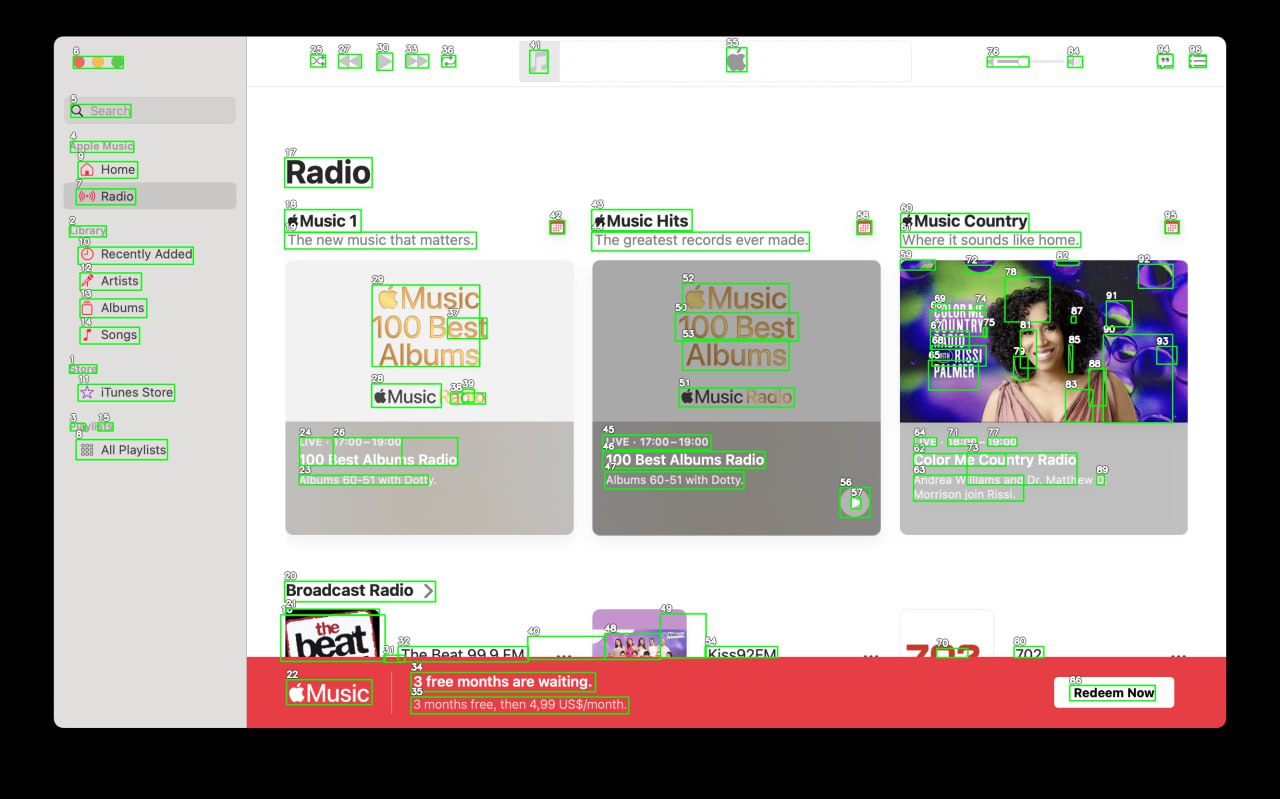Your task is to analyze the screenshot of the {app_name} on MacOS.  The screenshot is segmented with bounding boxes, each labeled with a number. The labels are always white numbers with a black outline. Number is always situated in the top left corner above the box. Segment the screen into logical parts, for example: top bar, main menu, ads bar etc. Provide as many categories as you can. Provide the output in JSON format connecting every category with list of numbers of the boxes that lie inside it.

For example,{
  "top_bar": [4, 7, 9, 13],
  "main_menu": [3, 8, 10, 15],
  "main_content": [6, 11, 12, 14, 16, 17],
  "ads_bar": [1, 2, 5]
}Note that you must find as many categories as you can, and can add subcategories inside of each of the categories.
 Based on the provided screenshot of the {app_name} on MacOS, here is the JSON structure that categorizes the various segments identified within the application's interface:

```json
{
  "sidebar": {
    "search": [5],
    "main_navigation": {
      "apple_music": [6],
      "home": [7],
      "radio": [8]
    },
    "library": {
      "recently_added": [10],
      "artists": [11],
      "albums": [12],
      "songs": [13]
    },
    "store": [14],
    "itunes_store": [15],
    "playlists": [16, 17, 18]
  },
  "main_content": {
    "top_banner": [22, 23, 24],
    "featured_content": {
      "music1": [25, 26],
      "music_hits": [27, 28, 29],
      "music_country": [30, 31, 32],
      "100_best_albums": [33, 34, 35]
    },
    "live_radio": [45, 46, 47],
    "broadcast_radio": [20, 21]
  },
  "ads_section": {
    "promotion_banner": [70, 71, 72]
  }
}
```

This JSON structure categorizes the application into several major areas: the sidebar (with further subdivisions for search, main navigation, library, store, iTunes store, and playlists), the main content area (with divisions for a top banner, featured content, live radio, and broadcast radio), and an ads section (including a promotion banner). Each category and subcategory is associated with the numbers of the boxes that fall within that segment, as seen in the screenshot with bounding boxes and labels. 